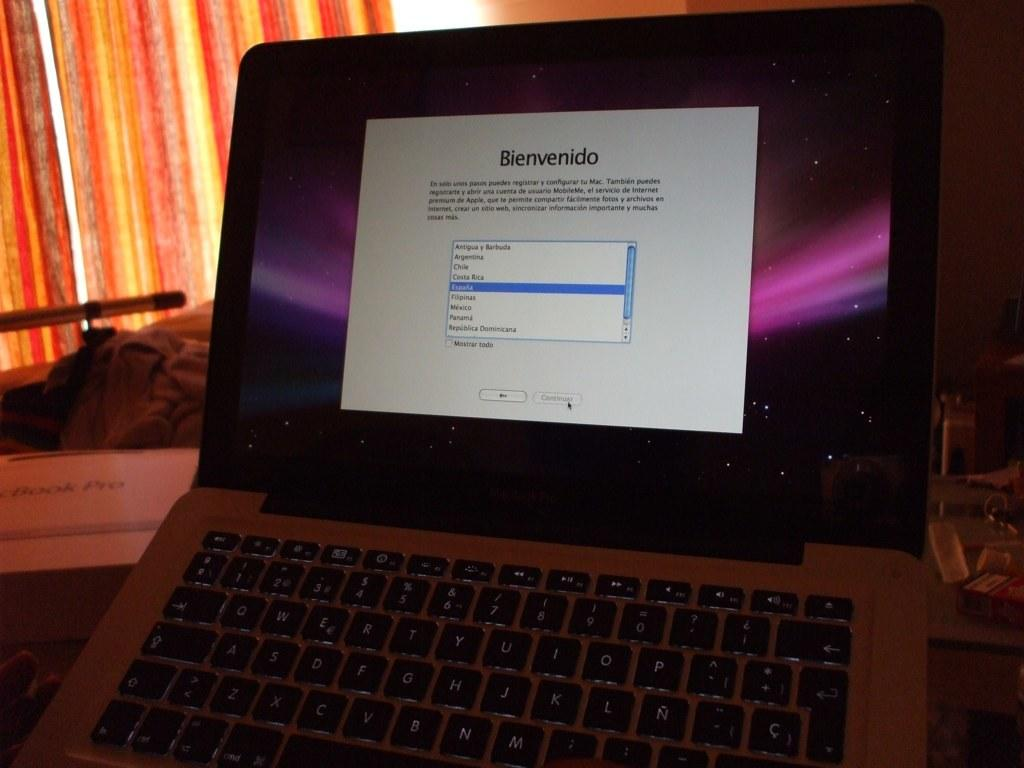Provide a one-sentence caption for the provided image. an open laptop with the word bienvendido on a white background. 